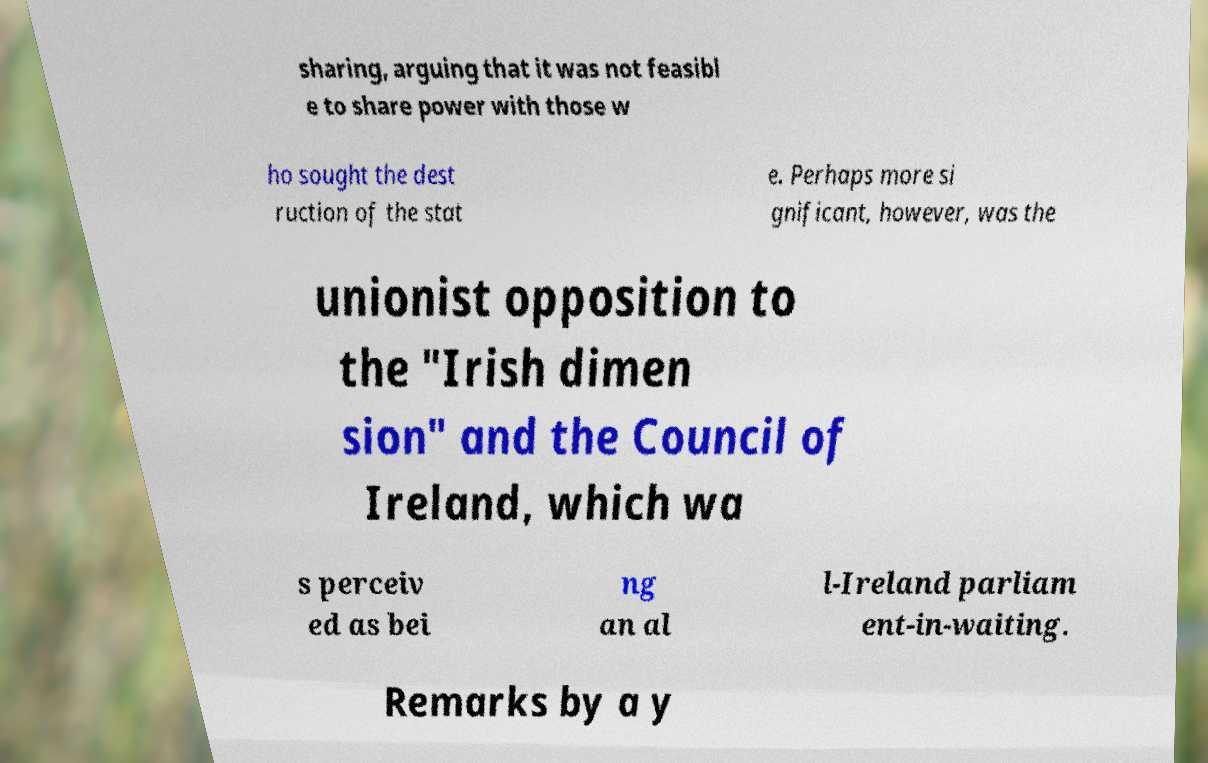There's text embedded in this image that I need extracted. Can you transcribe it verbatim? sharing, arguing that it was not feasibl e to share power with those w ho sought the dest ruction of the stat e. Perhaps more si gnificant, however, was the unionist opposition to the "Irish dimen sion" and the Council of Ireland, which wa s perceiv ed as bei ng an al l-Ireland parliam ent-in-waiting. Remarks by a y 